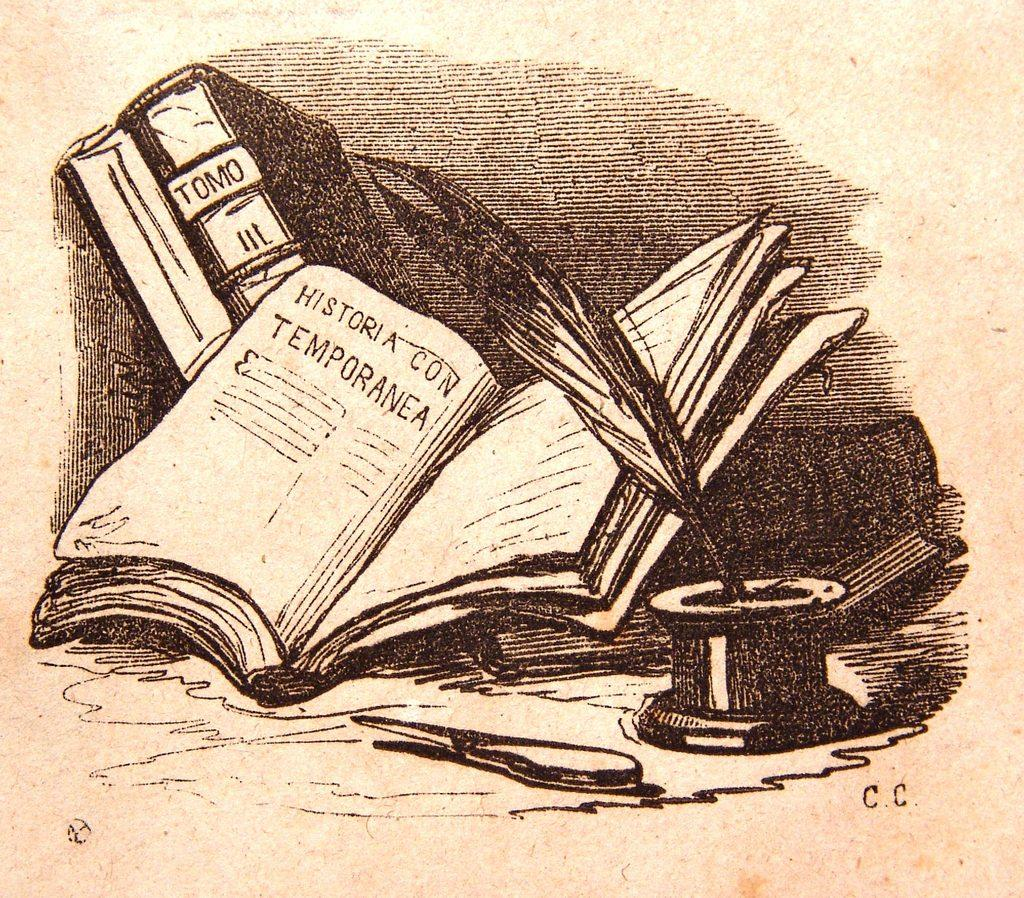<image>
Describe the image concisely. An illustration of a desktop and its contents shows a book with TOMO on the spine. 